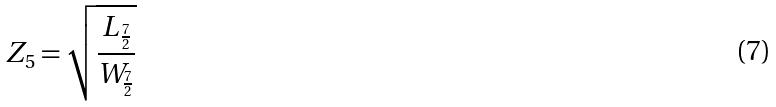<formula> <loc_0><loc_0><loc_500><loc_500>Z _ { 5 } = \sqrt { \frac { L _ { \frac { 7 } { 2 } } } { W _ { \frac { 7 } { 2 } } } }</formula> 